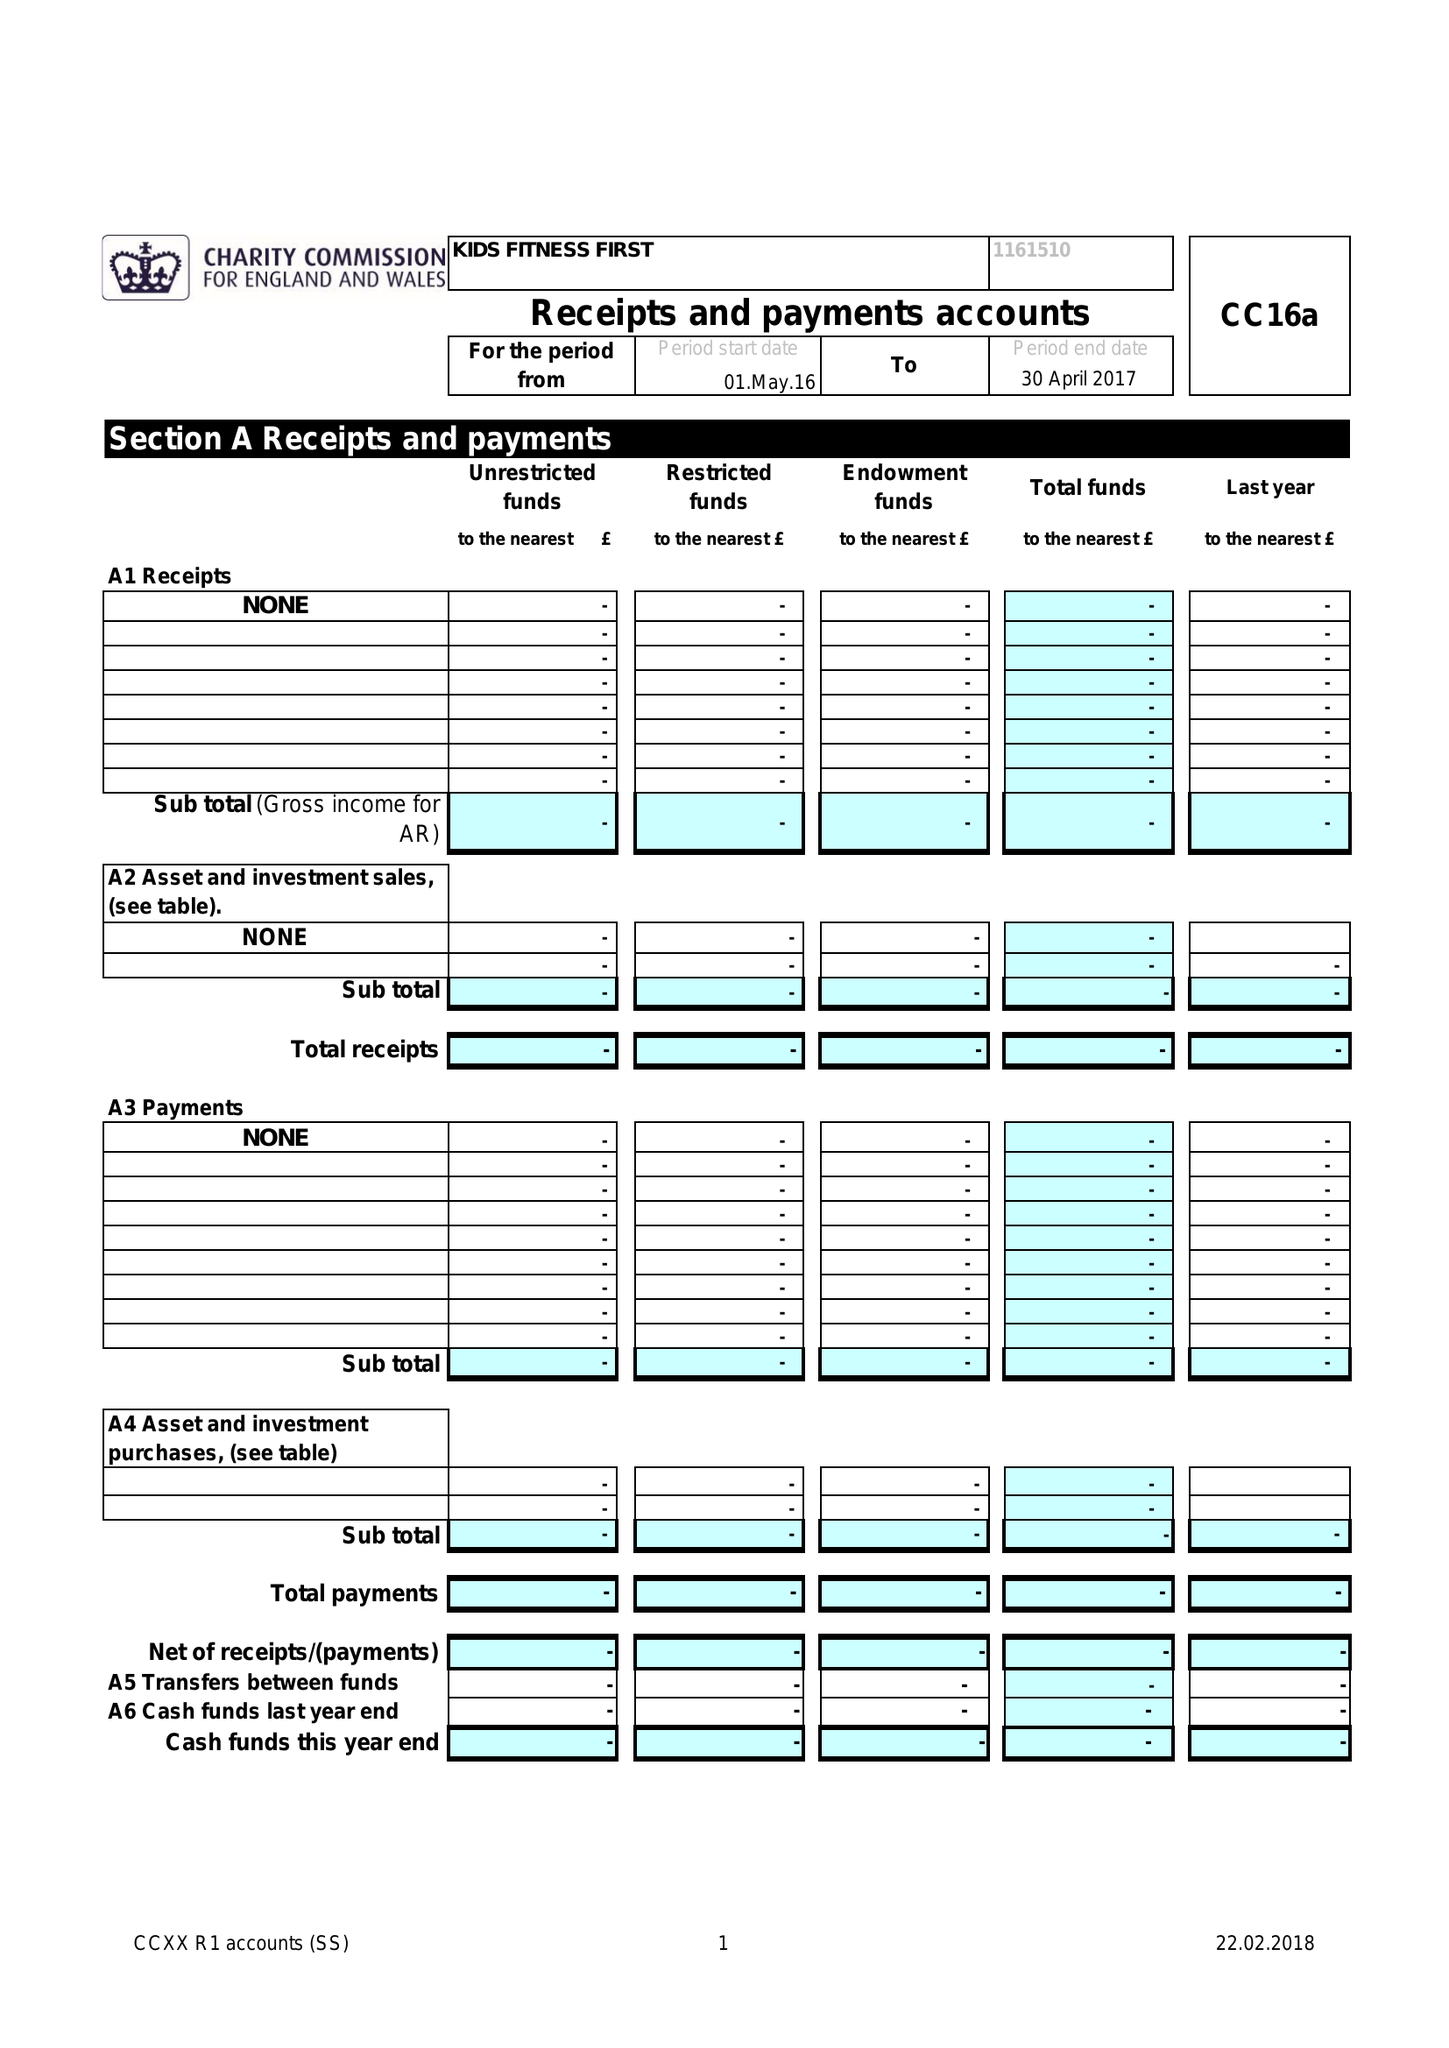What is the value for the charity_name?
Answer the question using a single word or phrase. Kids Fitness First 